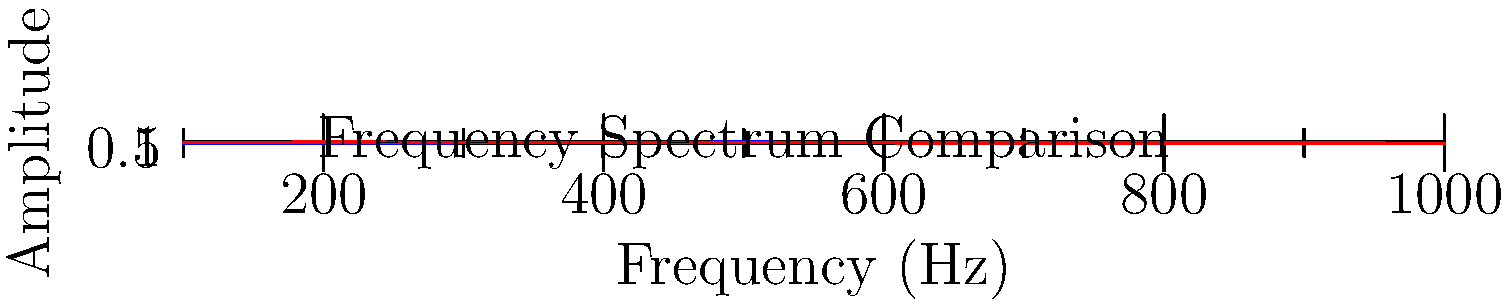As a producer working with a guitarist, you're analyzing the frequency spectrum of different guitar effects pedals. The graph shows the frequency response of a clean guitar signal (blue) and a distorted signal (red). Which of the following statements best describes the impact of the distortion pedal on the guitar's tone, and how might this affect the overall mix of the band? To answer this question, let's analyze the graph step-by-step:

1. Clean signal (blue line):
   - Peaks around 500 Hz
   - Gradually decreases in amplitude at higher and lower frequencies
   - Represents a more balanced, natural guitar tone

2. Distorted signal (red line):
   - Higher overall amplitude, especially in the lower frequencies (100-300 Hz)
   - More consistent amplitude across the frequency spectrum
   - Less pronounced peak, with a flatter response overall

3. Impact of distortion:
   - Increases the overall volume and presence of the guitar
   - Adds harmonics and overtones, especially in the lower and mid-range frequencies
   - Compresses the dynamic range, making the signal more consistent across frequencies

4. Effect on the mix:
   - The distorted signal will be more prominent in the mix due to its higher overall amplitude
   - It will occupy more of the frequency spectrum, potentially masking other instruments
   - The added harmonics and overtones will create a thicker, more complex sound
   - The compressed dynamic range may reduce the guitar's ability to breathe in the mix

5. Production considerations:
   - May need to adjust EQ to carve out space for other instruments
   - Could use the distortion to fill out the mid-range of the mix
   - Might need to be careful with volume levels to prevent the guitar from overpowering other elements
Answer: Distortion increases overall amplitude, adds harmonics, and compresses dynamic range, creating a more prominent and complex guitar tone that may require careful mixing to balance with other instruments. 